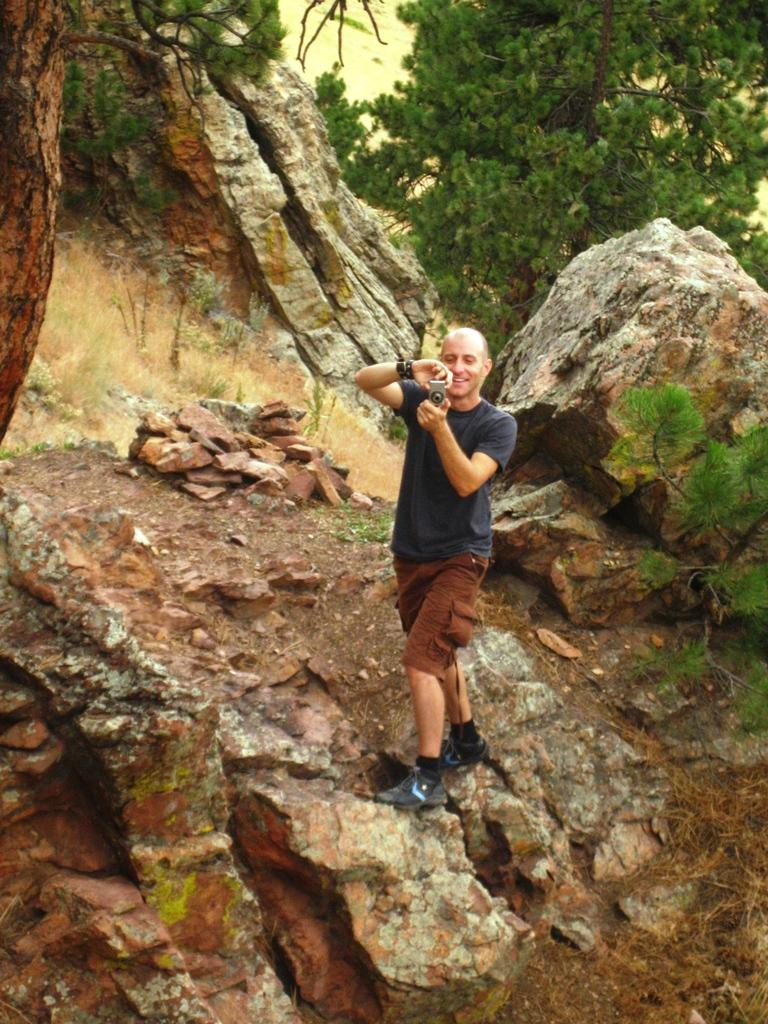What is the main subject of the image? There is a person in the image. What is the person wearing? The person is wearing a black color shirt and brown color shorts. What is the person holding in the image? The person is holding a camera. What can be seen in the background of the image? There are rocks and green-colored trees in the background of the image. What type of teaching is happening on the island in the image? There is no island or teaching activity present in the image. How many spiders are visible on the person's shirt in the image? There are no spiders visible on the person's shirt in the image. 